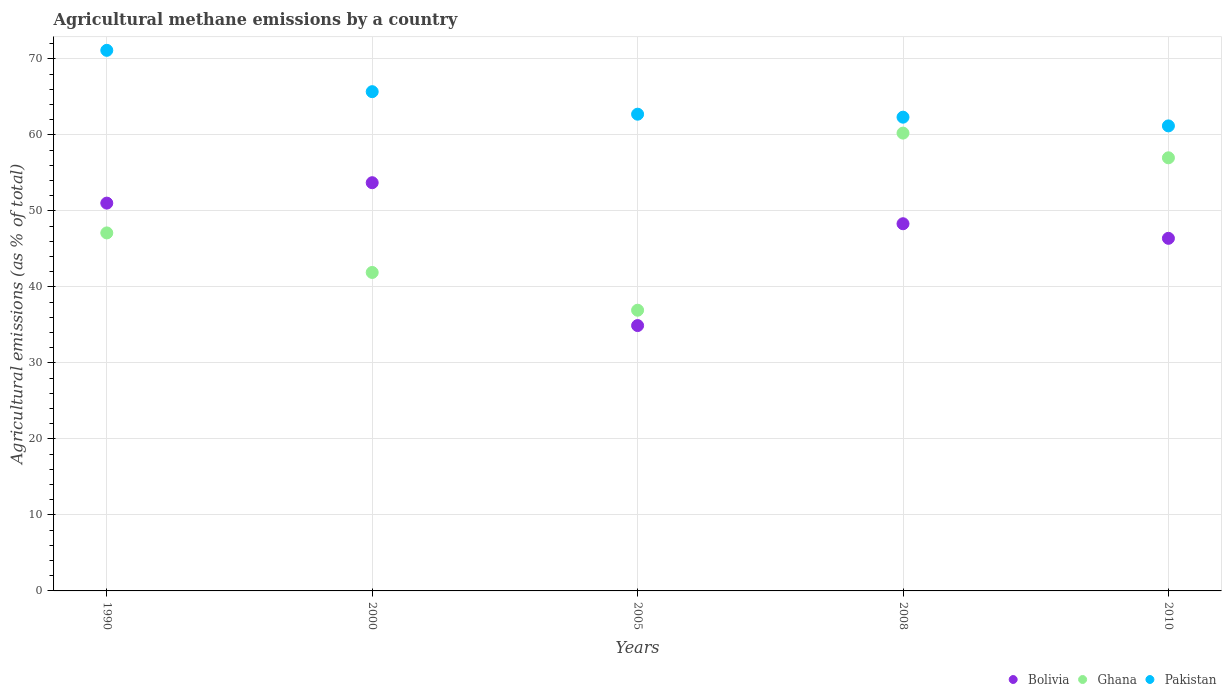What is the amount of agricultural methane emitted in Ghana in 2010?
Offer a very short reply. 56.99. Across all years, what is the maximum amount of agricultural methane emitted in Ghana?
Offer a terse response. 60.24. Across all years, what is the minimum amount of agricultural methane emitted in Pakistan?
Ensure brevity in your answer.  61.19. What is the total amount of agricultural methane emitted in Pakistan in the graph?
Give a very brief answer. 323.08. What is the difference between the amount of agricultural methane emitted in Bolivia in 1990 and that in 2000?
Your answer should be compact. -2.69. What is the difference between the amount of agricultural methane emitted in Pakistan in 2000 and the amount of agricultural methane emitted in Bolivia in 2005?
Offer a terse response. 30.78. What is the average amount of agricultural methane emitted in Ghana per year?
Offer a very short reply. 48.64. In the year 2010, what is the difference between the amount of agricultural methane emitted in Pakistan and amount of agricultural methane emitted in Bolivia?
Provide a succinct answer. 14.79. In how many years, is the amount of agricultural methane emitted in Pakistan greater than 54 %?
Provide a succinct answer. 5. What is the ratio of the amount of agricultural methane emitted in Bolivia in 1990 to that in 2008?
Offer a terse response. 1.06. Is the amount of agricultural methane emitted in Pakistan in 1990 less than that in 2010?
Provide a succinct answer. No. What is the difference between the highest and the second highest amount of agricultural methane emitted in Ghana?
Make the answer very short. 3.25. What is the difference between the highest and the lowest amount of agricultural methane emitted in Ghana?
Provide a succinct answer. 23.3. In how many years, is the amount of agricultural methane emitted in Ghana greater than the average amount of agricultural methane emitted in Ghana taken over all years?
Provide a succinct answer. 2. Is the sum of the amount of agricultural methane emitted in Ghana in 2008 and 2010 greater than the maximum amount of agricultural methane emitted in Bolivia across all years?
Your answer should be very brief. Yes. Is it the case that in every year, the sum of the amount of agricultural methane emitted in Ghana and amount of agricultural methane emitted in Bolivia  is greater than the amount of agricultural methane emitted in Pakistan?
Offer a terse response. Yes. How many dotlines are there?
Give a very brief answer. 3. What is the difference between two consecutive major ticks on the Y-axis?
Ensure brevity in your answer.  10. Are the values on the major ticks of Y-axis written in scientific E-notation?
Give a very brief answer. No. Does the graph contain any zero values?
Ensure brevity in your answer.  No. Does the graph contain grids?
Keep it short and to the point. Yes. Where does the legend appear in the graph?
Make the answer very short. Bottom right. What is the title of the graph?
Keep it short and to the point. Agricultural methane emissions by a country. Does "Malaysia" appear as one of the legend labels in the graph?
Ensure brevity in your answer.  No. What is the label or title of the X-axis?
Your answer should be compact. Years. What is the label or title of the Y-axis?
Ensure brevity in your answer.  Agricultural emissions (as % of total). What is the Agricultural emissions (as % of total) in Bolivia in 1990?
Give a very brief answer. 51.03. What is the Agricultural emissions (as % of total) in Ghana in 1990?
Provide a succinct answer. 47.11. What is the Agricultural emissions (as % of total) of Pakistan in 1990?
Provide a short and direct response. 71.13. What is the Agricultural emissions (as % of total) of Bolivia in 2000?
Your answer should be compact. 53.71. What is the Agricultural emissions (as % of total) of Ghana in 2000?
Offer a very short reply. 41.9. What is the Agricultural emissions (as % of total) in Pakistan in 2000?
Your answer should be compact. 65.69. What is the Agricultural emissions (as % of total) in Bolivia in 2005?
Your answer should be very brief. 34.92. What is the Agricultural emissions (as % of total) in Ghana in 2005?
Your answer should be very brief. 36.94. What is the Agricultural emissions (as % of total) of Pakistan in 2005?
Keep it short and to the point. 62.73. What is the Agricultural emissions (as % of total) in Bolivia in 2008?
Offer a terse response. 48.31. What is the Agricultural emissions (as % of total) in Ghana in 2008?
Ensure brevity in your answer.  60.24. What is the Agricultural emissions (as % of total) of Pakistan in 2008?
Provide a succinct answer. 62.34. What is the Agricultural emissions (as % of total) in Bolivia in 2010?
Ensure brevity in your answer.  46.4. What is the Agricultural emissions (as % of total) of Ghana in 2010?
Your response must be concise. 56.99. What is the Agricultural emissions (as % of total) of Pakistan in 2010?
Keep it short and to the point. 61.19. Across all years, what is the maximum Agricultural emissions (as % of total) in Bolivia?
Offer a very short reply. 53.71. Across all years, what is the maximum Agricultural emissions (as % of total) in Ghana?
Provide a succinct answer. 60.24. Across all years, what is the maximum Agricultural emissions (as % of total) in Pakistan?
Give a very brief answer. 71.13. Across all years, what is the minimum Agricultural emissions (as % of total) of Bolivia?
Your answer should be very brief. 34.92. Across all years, what is the minimum Agricultural emissions (as % of total) of Ghana?
Make the answer very short. 36.94. Across all years, what is the minimum Agricultural emissions (as % of total) in Pakistan?
Offer a terse response. 61.19. What is the total Agricultural emissions (as % of total) of Bolivia in the graph?
Provide a short and direct response. 234.37. What is the total Agricultural emissions (as % of total) in Ghana in the graph?
Provide a succinct answer. 243.18. What is the total Agricultural emissions (as % of total) of Pakistan in the graph?
Ensure brevity in your answer.  323.08. What is the difference between the Agricultural emissions (as % of total) of Bolivia in 1990 and that in 2000?
Provide a succinct answer. -2.69. What is the difference between the Agricultural emissions (as % of total) in Ghana in 1990 and that in 2000?
Offer a terse response. 5.2. What is the difference between the Agricultural emissions (as % of total) in Pakistan in 1990 and that in 2000?
Ensure brevity in your answer.  5.44. What is the difference between the Agricultural emissions (as % of total) in Bolivia in 1990 and that in 2005?
Your answer should be very brief. 16.11. What is the difference between the Agricultural emissions (as % of total) in Ghana in 1990 and that in 2005?
Ensure brevity in your answer.  10.17. What is the difference between the Agricultural emissions (as % of total) in Pakistan in 1990 and that in 2005?
Make the answer very short. 8.4. What is the difference between the Agricultural emissions (as % of total) of Bolivia in 1990 and that in 2008?
Offer a very short reply. 2.71. What is the difference between the Agricultural emissions (as % of total) of Ghana in 1990 and that in 2008?
Your answer should be compact. -13.13. What is the difference between the Agricultural emissions (as % of total) in Pakistan in 1990 and that in 2008?
Give a very brief answer. 8.79. What is the difference between the Agricultural emissions (as % of total) in Bolivia in 1990 and that in 2010?
Provide a short and direct response. 4.63. What is the difference between the Agricultural emissions (as % of total) in Ghana in 1990 and that in 2010?
Offer a terse response. -9.88. What is the difference between the Agricultural emissions (as % of total) in Pakistan in 1990 and that in 2010?
Your answer should be compact. 9.94. What is the difference between the Agricultural emissions (as % of total) in Bolivia in 2000 and that in 2005?
Your response must be concise. 18.8. What is the difference between the Agricultural emissions (as % of total) of Ghana in 2000 and that in 2005?
Keep it short and to the point. 4.97. What is the difference between the Agricultural emissions (as % of total) in Pakistan in 2000 and that in 2005?
Give a very brief answer. 2.96. What is the difference between the Agricultural emissions (as % of total) in Bolivia in 2000 and that in 2008?
Keep it short and to the point. 5.4. What is the difference between the Agricultural emissions (as % of total) of Ghana in 2000 and that in 2008?
Ensure brevity in your answer.  -18.34. What is the difference between the Agricultural emissions (as % of total) of Pakistan in 2000 and that in 2008?
Provide a succinct answer. 3.36. What is the difference between the Agricultural emissions (as % of total) in Bolivia in 2000 and that in 2010?
Provide a short and direct response. 7.32. What is the difference between the Agricultural emissions (as % of total) of Ghana in 2000 and that in 2010?
Your answer should be very brief. -15.09. What is the difference between the Agricultural emissions (as % of total) in Pakistan in 2000 and that in 2010?
Offer a very short reply. 4.5. What is the difference between the Agricultural emissions (as % of total) in Bolivia in 2005 and that in 2008?
Keep it short and to the point. -13.4. What is the difference between the Agricultural emissions (as % of total) in Ghana in 2005 and that in 2008?
Your answer should be very brief. -23.3. What is the difference between the Agricultural emissions (as % of total) in Pakistan in 2005 and that in 2008?
Give a very brief answer. 0.39. What is the difference between the Agricultural emissions (as % of total) of Bolivia in 2005 and that in 2010?
Keep it short and to the point. -11.48. What is the difference between the Agricultural emissions (as % of total) in Ghana in 2005 and that in 2010?
Give a very brief answer. -20.06. What is the difference between the Agricultural emissions (as % of total) in Pakistan in 2005 and that in 2010?
Your answer should be very brief. 1.54. What is the difference between the Agricultural emissions (as % of total) in Bolivia in 2008 and that in 2010?
Provide a succinct answer. 1.92. What is the difference between the Agricultural emissions (as % of total) in Ghana in 2008 and that in 2010?
Give a very brief answer. 3.25. What is the difference between the Agricultural emissions (as % of total) in Pakistan in 2008 and that in 2010?
Provide a succinct answer. 1.15. What is the difference between the Agricultural emissions (as % of total) in Bolivia in 1990 and the Agricultural emissions (as % of total) in Ghana in 2000?
Give a very brief answer. 9.12. What is the difference between the Agricultural emissions (as % of total) in Bolivia in 1990 and the Agricultural emissions (as % of total) in Pakistan in 2000?
Your response must be concise. -14.66. What is the difference between the Agricultural emissions (as % of total) of Ghana in 1990 and the Agricultural emissions (as % of total) of Pakistan in 2000?
Your answer should be very brief. -18.59. What is the difference between the Agricultural emissions (as % of total) in Bolivia in 1990 and the Agricultural emissions (as % of total) in Ghana in 2005?
Your response must be concise. 14.09. What is the difference between the Agricultural emissions (as % of total) of Bolivia in 1990 and the Agricultural emissions (as % of total) of Pakistan in 2005?
Ensure brevity in your answer.  -11.7. What is the difference between the Agricultural emissions (as % of total) of Ghana in 1990 and the Agricultural emissions (as % of total) of Pakistan in 2005?
Your answer should be very brief. -15.62. What is the difference between the Agricultural emissions (as % of total) of Bolivia in 1990 and the Agricultural emissions (as % of total) of Ghana in 2008?
Ensure brevity in your answer.  -9.21. What is the difference between the Agricultural emissions (as % of total) in Bolivia in 1990 and the Agricultural emissions (as % of total) in Pakistan in 2008?
Provide a succinct answer. -11.31. What is the difference between the Agricultural emissions (as % of total) of Ghana in 1990 and the Agricultural emissions (as % of total) of Pakistan in 2008?
Your answer should be very brief. -15.23. What is the difference between the Agricultural emissions (as % of total) of Bolivia in 1990 and the Agricultural emissions (as % of total) of Ghana in 2010?
Provide a short and direct response. -5.96. What is the difference between the Agricultural emissions (as % of total) of Bolivia in 1990 and the Agricultural emissions (as % of total) of Pakistan in 2010?
Your answer should be compact. -10.16. What is the difference between the Agricultural emissions (as % of total) of Ghana in 1990 and the Agricultural emissions (as % of total) of Pakistan in 2010?
Offer a very short reply. -14.08. What is the difference between the Agricultural emissions (as % of total) of Bolivia in 2000 and the Agricultural emissions (as % of total) of Ghana in 2005?
Provide a succinct answer. 16.78. What is the difference between the Agricultural emissions (as % of total) in Bolivia in 2000 and the Agricultural emissions (as % of total) in Pakistan in 2005?
Ensure brevity in your answer.  -9.01. What is the difference between the Agricultural emissions (as % of total) of Ghana in 2000 and the Agricultural emissions (as % of total) of Pakistan in 2005?
Give a very brief answer. -20.82. What is the difference between the Agricultural emissions (as % of total) of Bolivia in 2000 and the Agricultural emissions (as % of total) of Ghana in 2008?
Give a very brief answer. -6.53. What is the difference between the Agricultural emissions (as % of total) in Bolivia in 2000 and the Agricultural emissions (as % of total) in Pakistan in 2008?
Provide a short and direct response. -8.62. What is the difference between the Agricultural emissions (as % of total) in Ghana in 2000 and the Agricultural emissions (as % of total) in Pakistan in 2008?
Provide a short and direct response. -20.43. What is the difference between the Agricultural emissions (as % of total) in Bolivia in 2000 and the Agricultural emissions (as % of total) in Ghana in 2010?
Ensure brevity in your answer.  -3.28. What is the difference between the Agricultural emissions (as % of total) of Bolivia in 2000 and the Agricultural emissions (as % of total) of Pakistan in 2010?
Offer a very short reply. -7.48. What is the difference between the Agricultural emissions (as % of total) in Ghana in 2000 and the Agricultural emissions (as % of total) in Pakistan in 2010?
Give a very brief answer. -19.29. What is the difference between the Agricultural emissions (as % of total) in Bolivia in 2005 and the Agricultural emissions (as % of total) in Ghana in 2008?
Offer a very short reply. -25.32. What is the difference between the Agricultural emissions (as % of total) of Bolivia in 2005 and the Agricultural emissions (as % of total) of Pakistan in 2008?
Your answer should be compact. -27.42. What is the difference between the Agricultural emissions (as % of total) of Ghana in 2005 and the Agricultural emissions (as % of total) of Pakistan in 2008?
Offer a very short reply. -25.4. What is the difference between the Agricultural emissions (as % of total) in Bolivia in 2005 and the Agricultural emissions (as % of total) in Ghana in 2010?
Your response must be concise. -22.07. What is the difference between the Agricultural emissions (as % of total) in Bolivia in 2005 and the Agricultural emissions (as % of total) in Pakistan in 2010?
Your response must be concise. -26.27. What is the difference between the Agricultural emissions (as % of total) of Ghana in 2005 and the Agricultural emissions (as % of total) of Pakistan in 2010?
Offer a very short reply. -24.25. What is the difference between the Agricultural emissions (as % of total) in Bolivia in 2008 and the Agricultural emissions (as % of total) in Ghana in 2010?
Offer a very short reply. -8.68. What is the difference between the Agricultural emissions (as % of total) of Bolivia in 2008 and the Agricultural emissions (as % of total) of Pakistan in 2010?
Offer a very short reply. -12.88. What is the difference between the Agricultural emissions (as % of total) of Ghana in 2008 and the Agricultural emissions (as % of total) of Pakistan in 2010?
Keep it short and to the point. -0.95. What is the average Agricultural emissions (as % of total) in Bolivia per year?
Offer a terse response. 46.87. What is the average Agricultural emissions (as % of total) of Ghana per year?
Give a very brief answer. 48.64. What is the average Agricultural emissions (as % of total) in Pakistan per year?
Provide a short and direct response. 64.62. In the year 1990, what is the difference between the Agricultural emissions (as % of total) of Bolivia and Agricultural emissions (as % of total) of Ghana?
Make the answer very short. 3.92. In the year 1990, what is the difference between the Agricultural emissions (as % of total) of Bolivia and Agricultural emissions (as % of total) of Pakistan?
Your response must be concise. -20.1. In the year 1990, what is the difference between the Agricultural emissions (as % of total) of Ghana and Agricultural emissions (as % of total) of Pakistan?
Offer a very short reply. -24.02. In the year 2000, what is the difference between the Agricultural emissions (as % of total) of Bolivia and Agricultural emissions (as % of total) of Ghana?
Provide a succinct answer. 11.81. In the year 2000, what is the difference between the Agricultural emissions (as % of total) of Bolivia and Agricultural emissions (as % of total) of Pakistan?
Make the answer very short. -11.98. In the year 2000, what is the difference between the Agricultural emissions (as % of total) in Ghana and Agricultural emissions (as % of total) in Pakistan?
Provide a short and direct response. -23.79. In the year 2005, what is the difference between the Agricultural emissions (as % of total) in Bolivia and Agricultural emissions (as % of total) in Ghana?
Your response must be concise. -2.02. In the year 2005, what is the difference between the Agricultural emissions (as % of total) of Bolivia and Agricultural emissions (as % of total) of Pakistan?
Make the answer very short. -27.81. In the year 2005, what is the difference between the Agricultural emissions (as % of total) in Ghana and Agricultural emissions (as % of total) in Pakistan?
Provide a succinct answer. -25.79. In the year 2008, what is the difference between the Agricultural emissions (as % of total) in Bolivia and Agricultural emissions (as % of total) in Ghana?
Offer a very short reply. -11.93. In the year 2008, what is the difference between the Agricultural emissions (as % of total) in Bolivia and Agricultural emissions (as % of total) in Pakistan?
Provide a short and direct response. -14.02. In the year 2008, what is the difference between the Agricultural emissions (as % of total) of Ghana and Agricultural emissions (as % of total) of Pakistan?
Your response must be concise. -2.1. In the year 2010, what is the difference between the Agricultural emissions (as % of total) in Bolivia and Agricultural emissions (as % of total) in Ghana?
Give a very brief answer. -10.6. In the year 2010, what is the difference between the Agricultural emissions (as % of total) of Bolivia and Agricultural emissions (as % of total) of Pakistan?
Offer a terse response. -14.79. In the year 2010, what is the difference between the Agricultural emissions (as % of total) of Ghana and Agricultural emissions (as % of total) of Pakistan?
Make the answer very short. -4.2. What is the ratio of the Agricultural emissions (as % of total) in Ghana in 1990 to that in 2000?
Keep it short and to the point. 1.12. What is the ratio of the Agricultural emissions (as % of total) in Pakistan in 1990 to that in 2000?
Your answer should be very brief. 1.08. What is the ratio of the Agricultural emissions (as % of total) of Bolivia in 1990 to that in 2005?
Your response must be concise. 1.46. What is the ratio of the Agricultural emissions (as % of total) of Ghana in 1990 to that in 2005?
Offer a terse response. 1.28. What is the ratio of the Agricultural emissions (as % of total) of Pakistan in 1990 to that in 2005?
Your response must be concise. 1.13. What is the ratio of the Agricultural emissions (as % of total) in Bolivia in 1990 to that in 2008?
Make the answer very short. 1.06. What is the ratio of the Agricultural emissions (as % of total) in Ghana in 1990 to that in 2008?
Provide a short and direct response. 0.78. What is the ratio of the Agricultural emissions (as % of total) in Pakistan in 1990 to that in 2008?
Your answer should be very brief. 1.14. What is the ratio of the Agricultural emissions (as % of total) of Bolivia in 1990 to that in 2010?
Make the answer very short. 1.1. What is the ratio of the Agricultural emissions (as % of total) in Ghana in 1990 to that in 2010?
Provide a succinct answer. 0.83. What is the ratio of the Agricultural emissions (as % of total) of Pakistan in 1990 to that in 2010?
Provide a succinct answer. 1.16. What is the ratio of the Agricultural emissions (as % of total) of Bolivia in 2000 to that in 2005?
Give a very brief answer. 1.54. What is the ratio of the Agricultural emissions (as % of total) in Ghana in 2000 to that in 2005?
Ensure brevity in your answer.  1.13. What is the ratio of the Agricultural emissions (as % of total) of Pakistan in 2000 to that in 2005?
Provide a short and direct response. 1.05. What is the ratio of the Agricultural emissions (as % of total) of Bolivia in 2000 to that in 2008?
Give a very brief answer. 1.11. What is the ratio of the Agricultural emissions (as % of total) in Ghana in 2000 to that in 2008?
Keep it short and to the point. 0.7. What is the ratio of the Agricultural emissions (as % of total) of Pakistan in 2000 to that in 2008?
Your response must be concise. 1.05. What is the ratio of the Agricultural emissions (as % of total) of Bolivia in 2000 to that in 2010?
Provide a succinct answer. 1.16. What is the ratio of the Agricultural emissions (as % of total) of Ghana in 2000 to that in 2010?
Give a very brief answer. 0.74. What is the ratio of the Agricultural emissions (as % of total) in Pakistan in 2000 to that in 2010?
Provide a short and direct response. 1.07. What is the ratio of the Agricultural emissions (as % of total) of Bolivia in 2005 to that in 2008?
Your response must be concise. 0.72. What is the ratio of the Agricultural emissions (as % of total) in Ghana in 2005 to that in 2008?
Offer a terse response. 0.61. What is the ratio of the Agricultural emissions (as % of total) of Pakistan in 2005 to that in 2008?
Your answer should be very brief. 1.01. What is the ratio of the Agricultural emissions (as % of total) of Bolivia in 2005 to that in 2010?
Give a very brief answer. 0.75. What is the ratio of the Agricultural emissions (as % of total) in Ghana in 2005 to that in 2010?
Provide a succinct answer. 0.65. What is the ratio of the Agricultural emissions (as % of total) of Pakistan in 2005 to that in 2010?
Your answer should be compact. 1.03. What is the ratio of the Agricultural emissions (as % of total) of Bolivia in 2008 to that in 2010?
Keep it short and to the point. 1.04. What is the ratio of the Agricultural emissions (as % of total) in Ghana in 2008 to that in 2010?
Make the answer very short. 1.06. What is the ratio of the Agricultural emissions (as % of total) of Pakistan in 2008 to that in 2010?
Provide a short and direct response. 1.02. What is the difference between the highest and the second highest Agricultural emissions (as % of total) of Bolivia?
Your response must be concise. 2.69. What is the difference between the highest and the second highest Agricultural emissions (as % of total) of Ghana?
Make the answer very short. 3.25. What is the difference between the highest and the second highest Agricultural emissions (as % of total) of Pakistan?
Offer a very short reply. 5.44. What is the difference between the highest and the lowest Agricultural emissions (as % of total) in Bolivia?
Keep it short and to the point. 18.8. What is the difference between the highest and the lowest Agricultural emissions (as % of total) of Ghana?
Keep it short and to the point. 23.3. What is the difference between the highest and the lowest Agricultural emissions (as % of total) in Pakistan?
Provide a succinct answer. 9.94. 